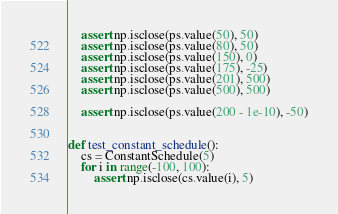Convert code to text. <code><loc_0><loc_0><loc_500><loc_500><_Python_>    assert np.isclose(ps.value(50), 50)
    assert np.isclose(ps.value(80), 50)
    assert np.isclose(ps.value(150), 0)
    assert np.isclose(ps.value(175), -25)
    assert np.isclose(ps.value(201), 500)
    assert np.isclose(ps.value(500), 500)

    assert np.isclose(ps.value(200 - 1e-10), -50)


def test_constant_schedule():
    cs = ConstantSchedule(5)
    for i in range(-100, 100):
        assert np.isclose(cs.value(i), 5)
</code> 